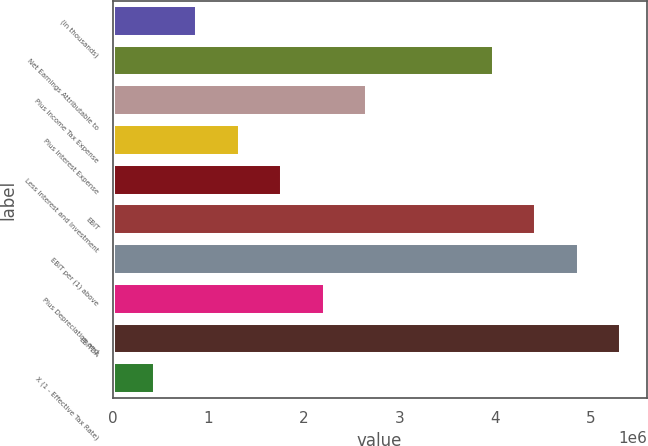Convert chart to OTSL. <chart><loc_0><loc_0><loc_500><loc_500><bar_chart><fcel>(in thousands)<fcel>Net Earnings Attributable to<fcel>Plus Income Tax Expense<fcel>Plus Interest Expense<fcel>Less Interest and Investment<fcel>EBIT<fcel>EBIT per (1) above<fcel>Plus Depreciation and<fcel>EBITDA<fcel>X (1 - Effective Tax Rate)<nl><fcel>886652<fcel>3.98988e+06<fcel>2.65992e+06<fcel>1.32997e+06<fcel>1.77329e+06<fcel>4.4332e+06<fcel>4.87652e+06<fcel>2.21661e+06<fcel>5.31983e+06<fcel>443334<nl></chart> 